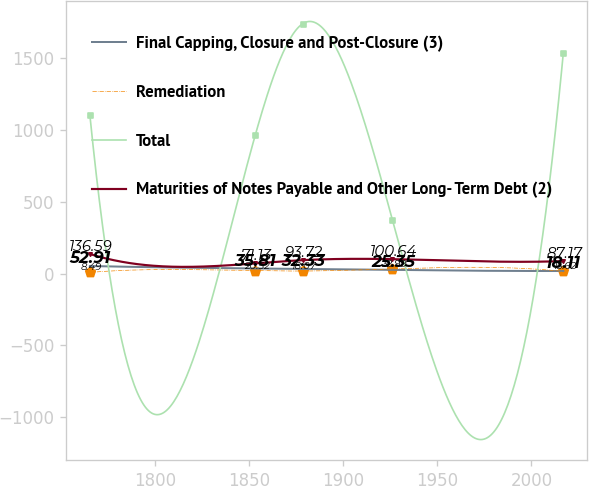<chart> <loc_0><loc_0><loc_500><loc_500><line_chart><ecel><fcel>Final Capping, Closure and Post-Closure (3)<fcel>Remediation<fcel>Total<fcel>Maturities of Notes Payable and Other Long- Term Debt (2)<nl><fcel>1765.27<fcel>52.91<fcel>8.49<fcel>1102.34<fcel>136.59<nl><fcel>1853.23<fcel>35.81<fcel>20.52<fcel>965.87<fcel>71.13<nl><fcel>1878.4<fcel>32.33<fcel>18.07<fcel>1740.2<fcel>93.72<nl><fcel>1926.11<fcel>25.35<fcel>32.99<fcel>375.51<fcel>100.64<nl><fcel>2017<fcel>18.11<fcel>15.62<fcel>1536.12<fcel>87.17<nl></chart> 